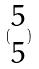Convert formula to latex. <formula><loc_0><loc_0><loc_500><loc_500>( \begin{matrix} 5 \\ 5 \end{matrix} )</formula> 